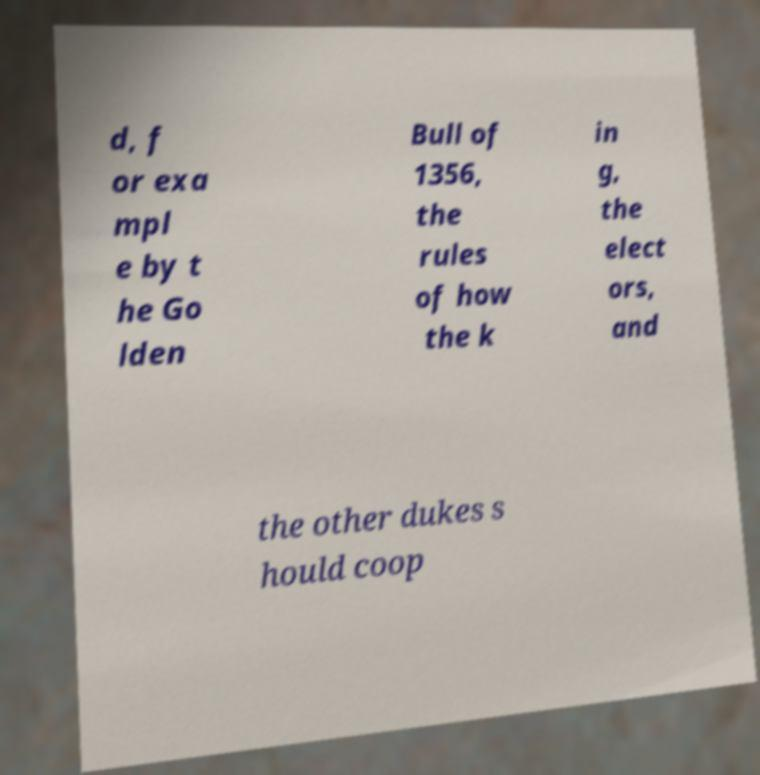Could you assist in decoding the text presented in this image and type it out clearly? d, f or exa mpl e by t he Go lden Bull of 1356, the rules of how the k in g, the elect ors, and the other dukes s hould coop 